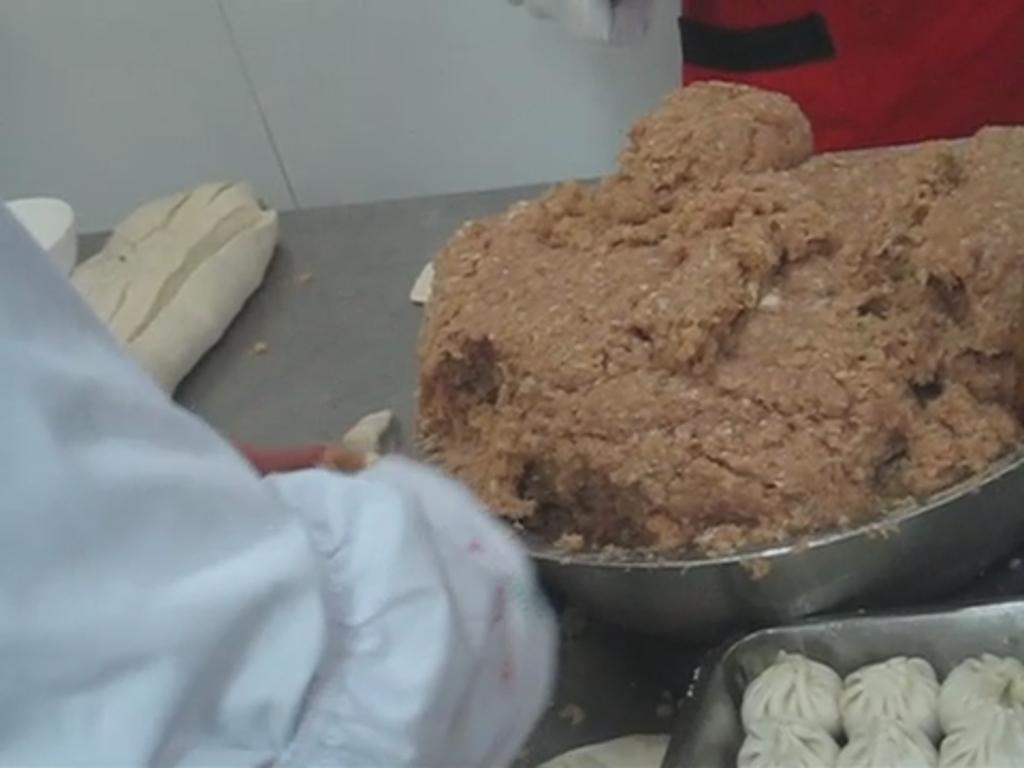Please provide a concise description of this image. In this image, we can see food items and there are containers on the table. In the background, we can see people and there is a wall. 